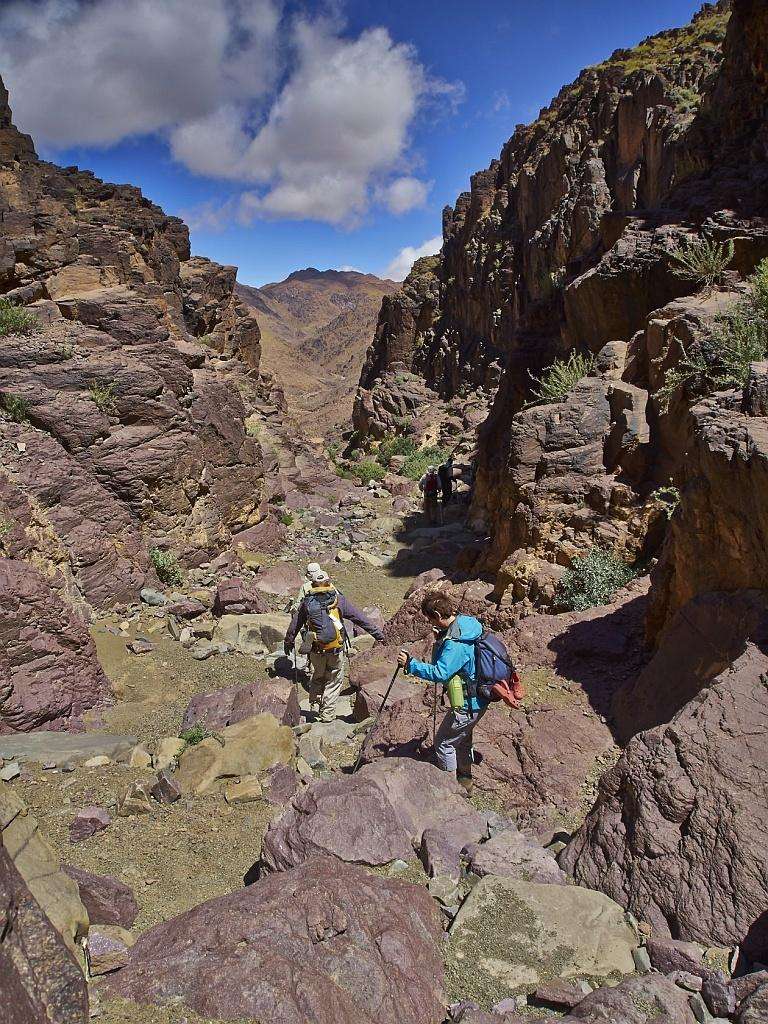What type of natural formation can be seen in the image? There are mountains in the image. What are the persons in the image doing? The persons are walking on the ground and holding sticks. What can be seen in the background of the image? There are plants and a cloudy sky in the background of the image. What type of drain is visible in the image? There is no drain present in the image. What suggestion do the persons in the image have for improving the landscape? The image does not provide any information about suggestions or improvements, as it only shows persons walking with sticks and the surrounding environment. 